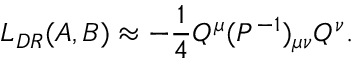<formula> <loc_0><loc_0><loc_500><loc_500>L _ { D R } ( A , B ) \approx - { \frac { 1 } { 4 } } Q ^ { \mu } ( P ^ { - 1 } ) _ { \mu \nu } Q ^ { \nu } .</formula> 